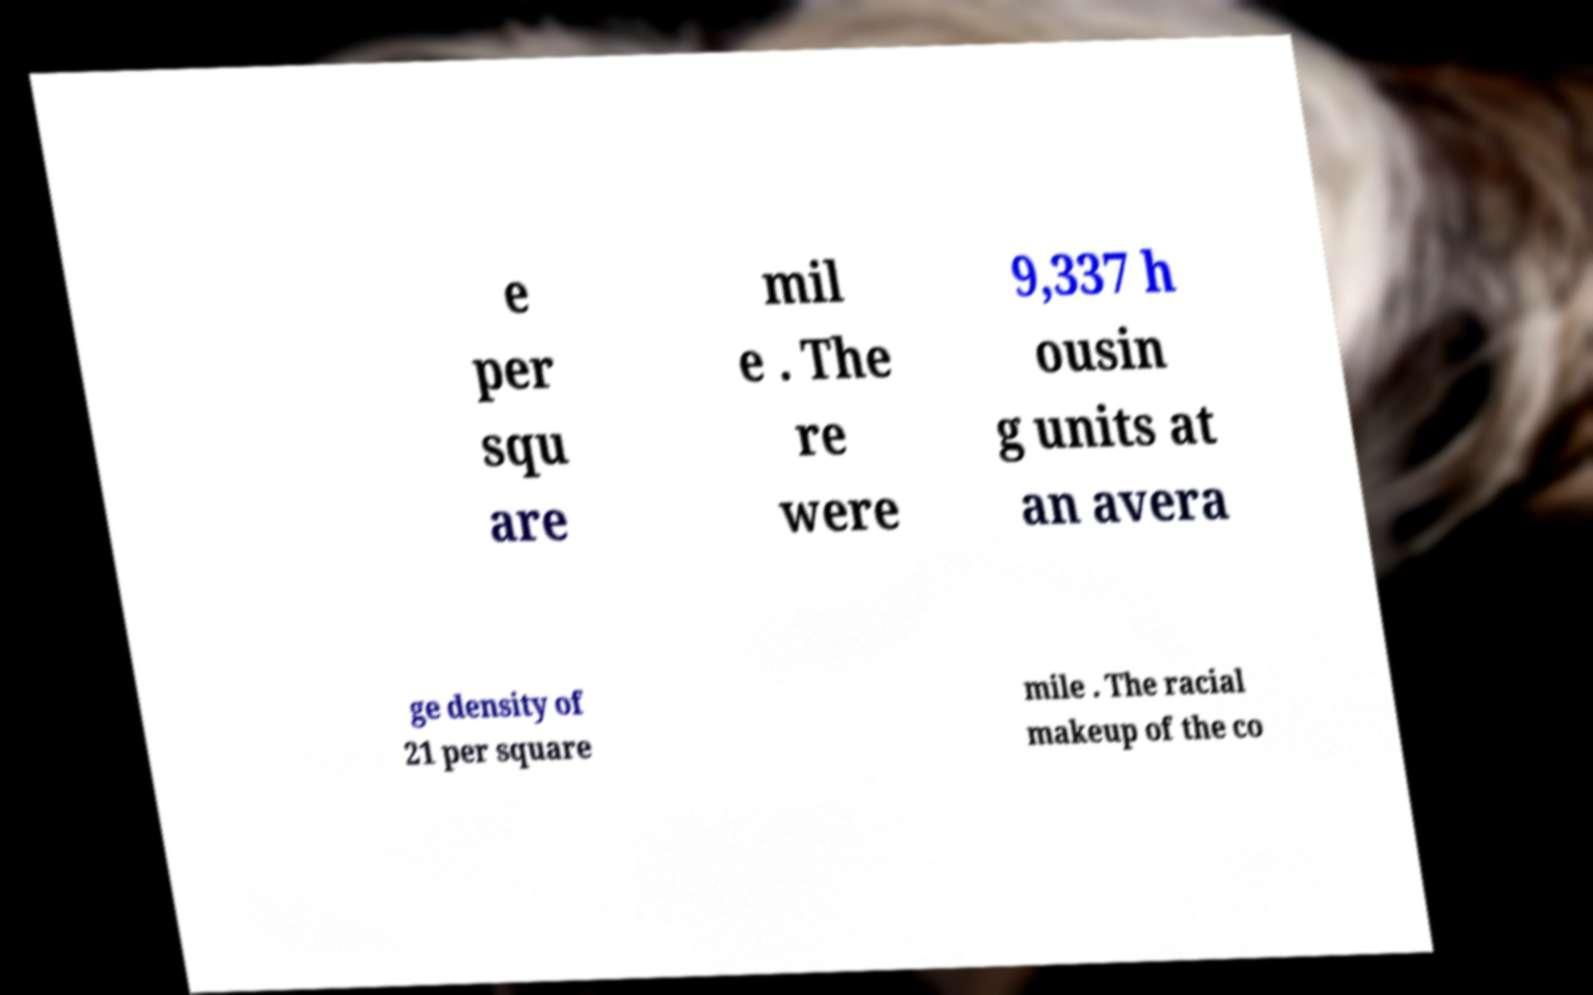Could you assist in decoding the text presented in this image and type it out clearly? e per squ are mil e . The re were 9,337 h ousin g units at an avera ge density of 21 per square mile . The racial makeup of the co 